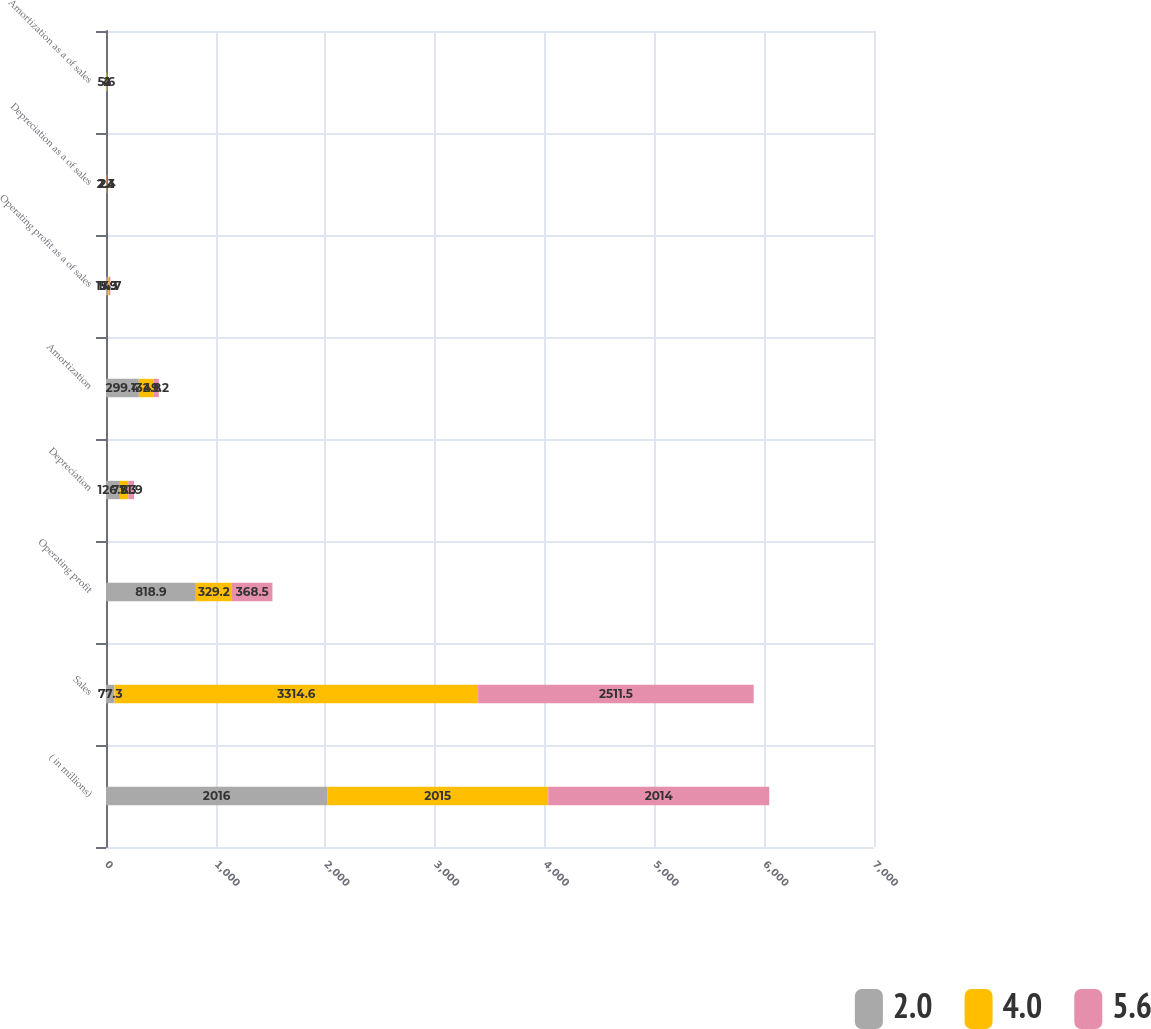Convert chart. <chart><loc_0><loc_0><loc_500><loc_500><stacked_bar_chart><ecel><fcel>( in millions)<fcel>Sales<fcel>Operating profit<fcel>Depreciation<fcel>Amortization<fcel>Operating profit as a of sales<fcel>Depreciation as a of sales<fcel>Amortization as a of sales<nl><fcel>2<fcel>2016<fcel>77.3<fcel>818.9<fcel>126.8<fcel>299.4<fcel>15.3<fcel>2.4<fcel>5.6<nl><fcel>4<fcel>2015<fcel>3314.6<fcel>329.2<fcel>77.3<fcel>132.8<fcel>9.9<fcel>2.3<fcel>4<nl><fcel>5.6<fcel>2014<fcel>2511.5<fcel>368.5<fcel>51.9<fcel>49.2<fcel>14.7<fcel>2.1<fcel>2<nl></chart> 